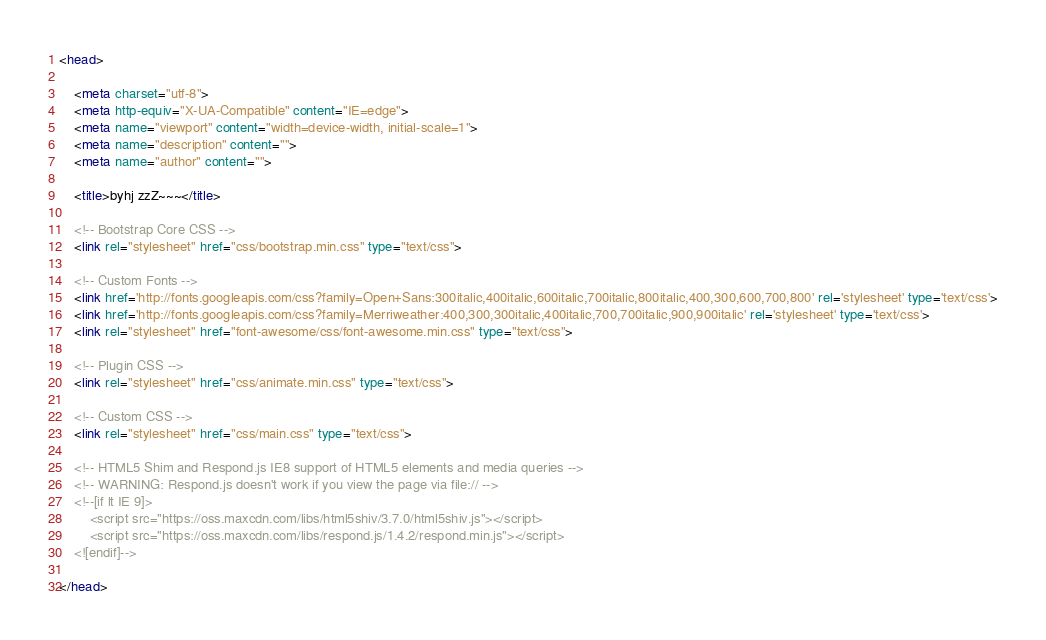<code> <loc_0><loc_0><loc_500><loc_500><_HTML_><head>

    <meta charset="utf-8">
    <meta http-equiv="X-UA-Compatible" content="IE=edge">
    <meta name="viewport" content="width=device-width, initial-scale=1">
    <meta name="description" content="">
    <meta name="author" content="">

    <title>byhj zzZ~~~</title>

    <!-- Bootstrap Core CSS -->
    <link rel="stylesheet" href="css/bootstrap.min.css" type="text/css">

    <!-- Custom Fonts -->
    <link href='http://fonts.googleapis.com/css?family=Open+Sans:300italic,400italic,600italic,700italic,800italic,400,300,600,700,800' rel='stylesheet' type='text/css'>
    <link href='http://fonts.googleapis.com/css?family=Merriweather:400,300,300italic,400italic,700,700italic,900,900italic' rel='stylesheet' type='text/css'>
    <link rel="stylesheet" href="font-awesome/css/font-awesome.min.css" type="text/css">

    <!-- Plugin CSS -->
    <link rel="stylesheet" href="css/animate.min.css" type="text/css">

    <!-- Custom CSS -->
    <link rel="stylesheet" href="css/main.css" type="text/css">

    <!-- HTML5 Shim and Respond.js IE8 support of HTML5 elements and media queries -->
    <!-- WARNING: Respond.js doesn't work if you view the page via file:// -->
    <!--[if lt IE 9]>
        <script src="https://oss.maxcdn.com/libs/html5shiv/3.7.0/html5shiv.js"></script>
        <script src="https://oss.maxcdn.com/libs/respond.js/1.4.2/respond.min.js"></script>
    <![endif]-->

</head>
</code> 